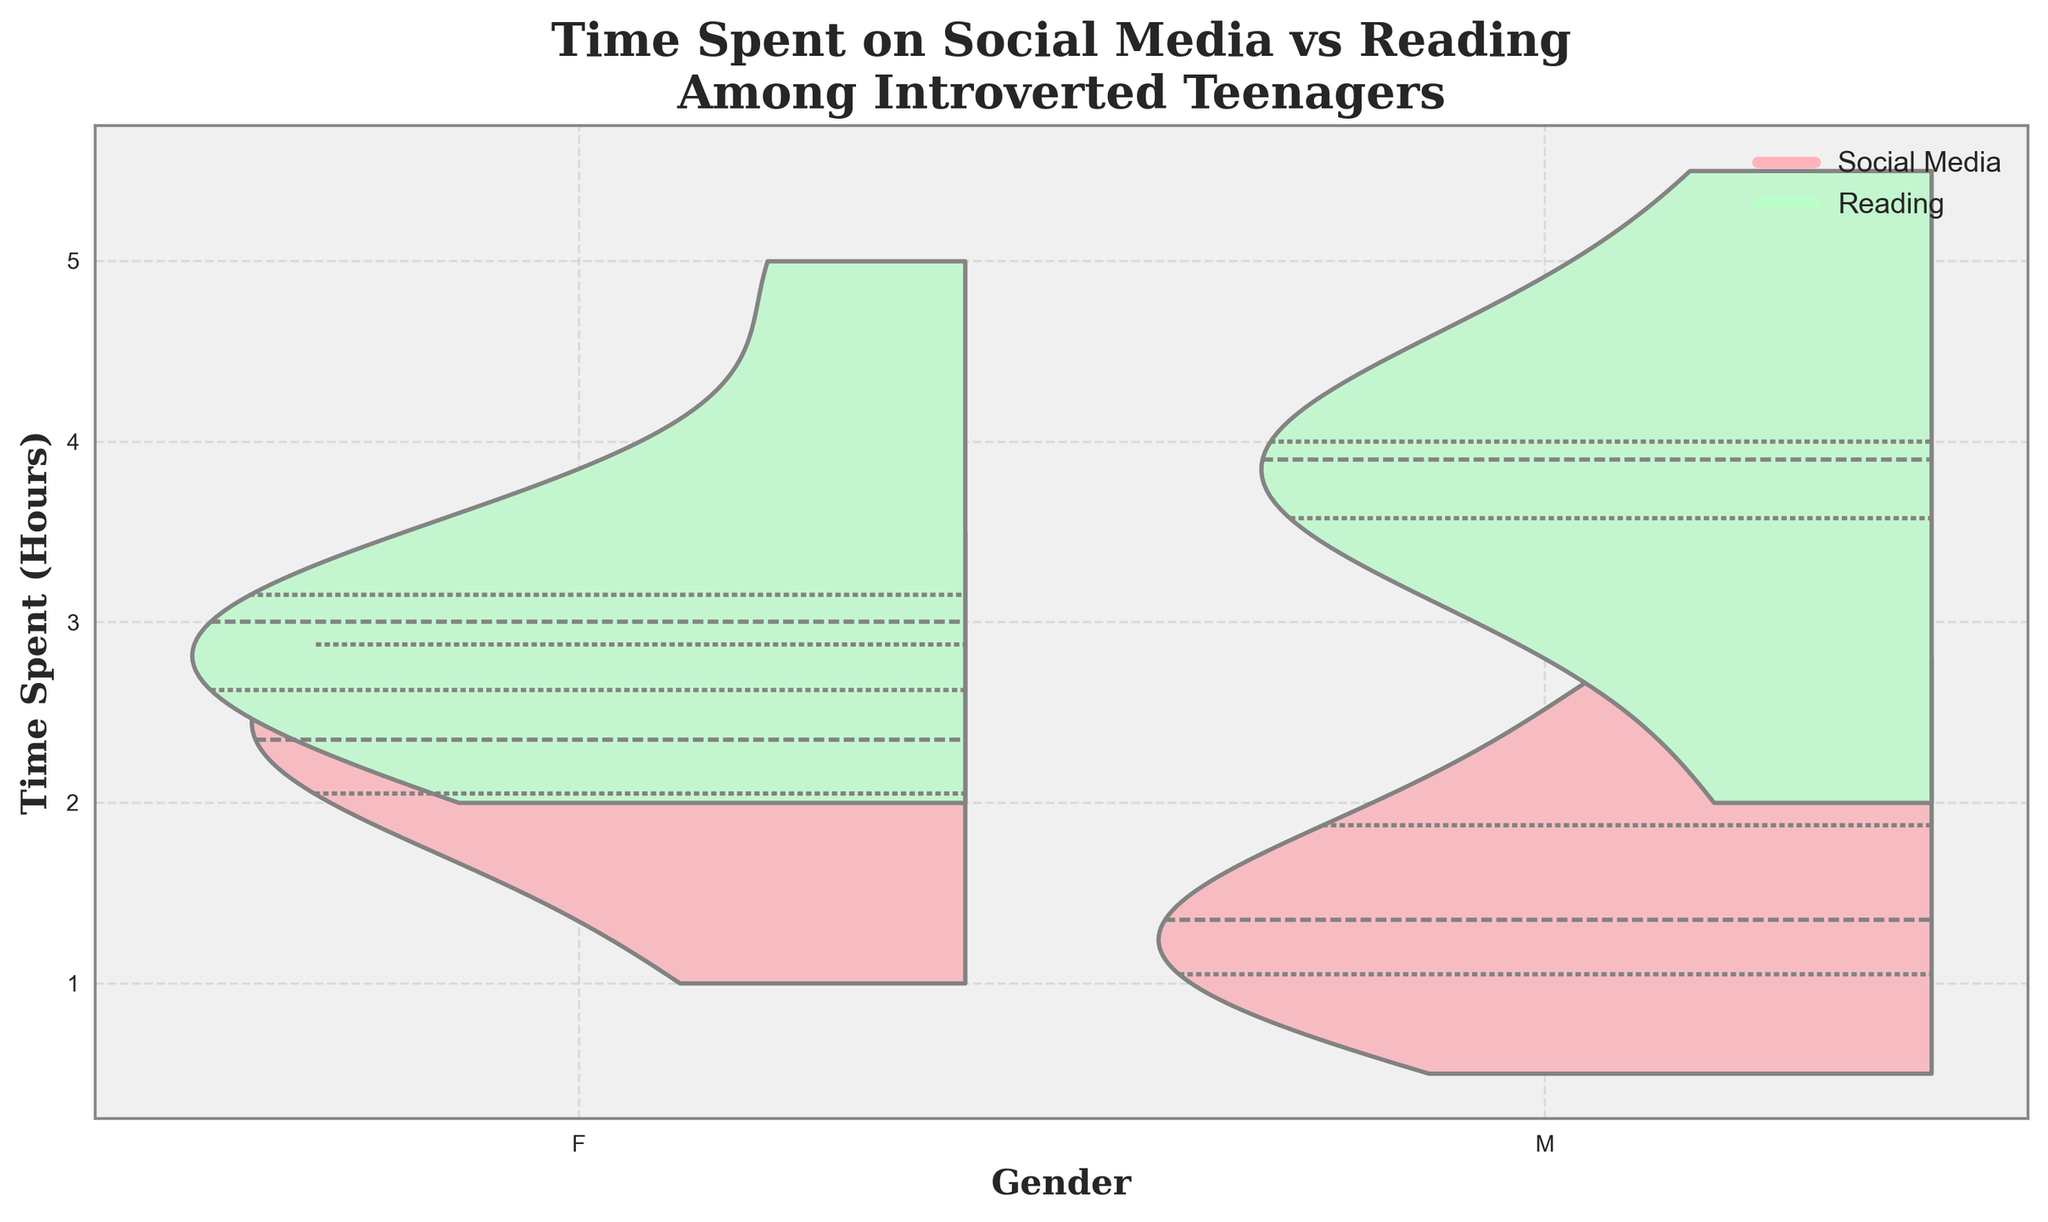What is the title of the chart? The title of the chart is usually found at the top and describes what the chart is about.
Answer: "Time Spent on Social Media vs Reading Among Introverted Teenagers" What colors are used to represent social media and reading time? Noticeable differences in colors are used to distinguish between categories. Social media is represented by a pinkish color, and reading time by a greenish color.
Answer: Pink for social media and green for reading Which gender spends more time on social media on average? Look at the width of the pink areas for each gender to observe which one is larger, indicating more time spent on social media on average.
Answer: Females Which gender spends more time reading on average? Look at the width of the green areas for each gender to observe which one is larger, indicating more time spent reading on average.
Answer: Males What is the y-axis label? The y-axis label is usually on the left side of the chart and tells what the vertical scale represents.
Answer: "Time Spent (Hours)" How are the medians of time spent on social media for both genders different? Observe the centerline in the pink area which represents the median. Compare the position of these lines for both genders.
Answer: The median is higher for females than males What is the approximate maximum time spent on reading for males? Examine the uppermost point of the green area for males to estimate the maximum time spent reading.
Answer: Approximately 5.5 hours Is there more variance in time spent on social media or reading for both genders? Look at the spread of the pink and green areas. The wider the spread, the more the variance. Compare the spreads for both activities across genders.
Answer: More variance in reading Is the time spent on social media more concentrated for any gender? Check the density and spread of the pink area. High density (narrow spread) indicates more concentration.
Answer: Yes, for males What is the range of time spent on social media for females? Identify the lowest and highest points of the pink area for females and subtract the lowest from the highest to determine the range.
Answer: 0.5 to 3.5 hours 